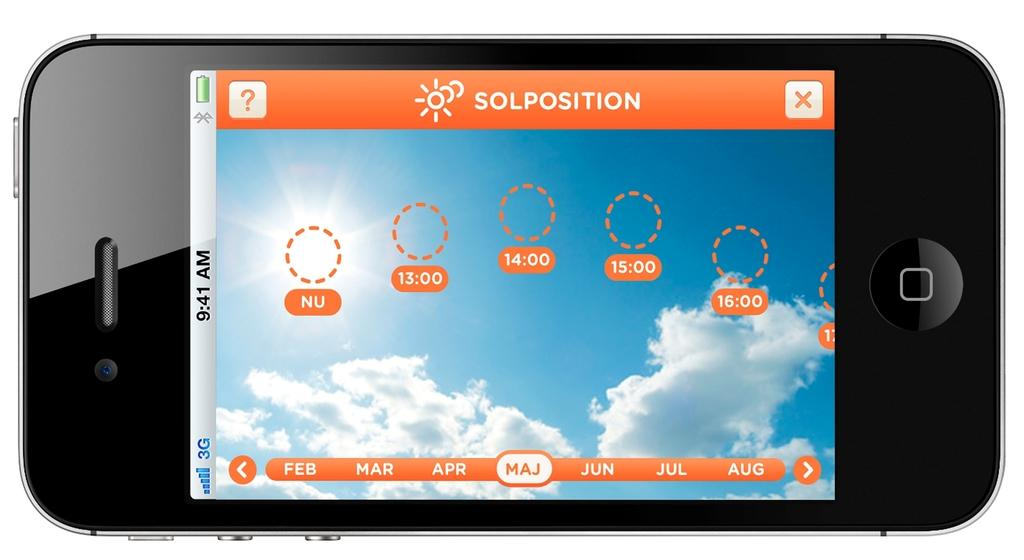What type of phone is in the image? There is a black color phone in the image. What is displayed on the phone's screen? There is writing on the phone's screen. What can be seen in the sky in the image? The sky is visible in the image, and there are clouds and the sun present. What type of heart-shaped curve can be seen on the phone's screen? There is no heart-shaped curve present on the phone's screen in the image. 